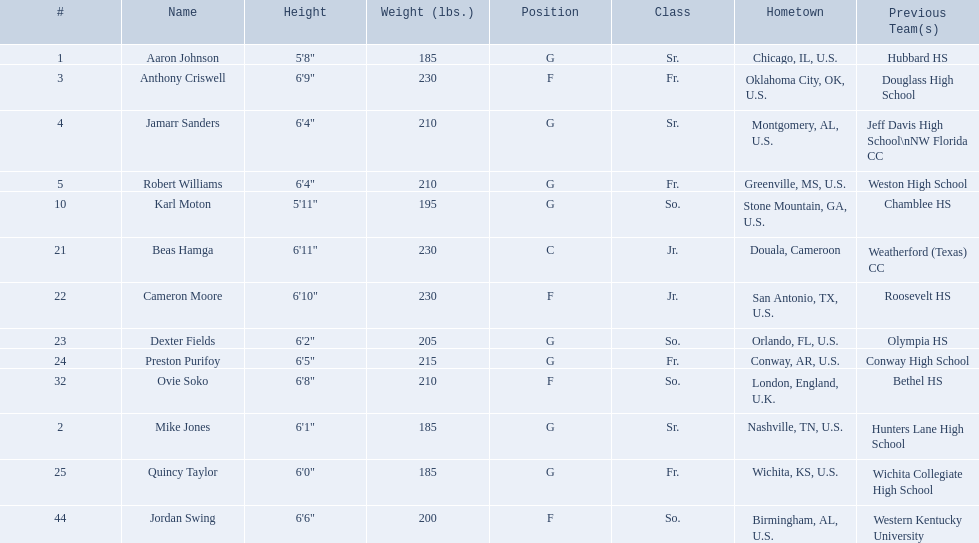Who are the complete list of players? Aaron Johnson, Anthony Criswell, Jamarr Sanders, Robert Williams, Karl Moton, Beas Hamga, Cameron Moore, Dexter Fields, Preston Purifoy, Ovie Soko, Mike Jones, Quincy Taylor, Jordan Swing. Which players come from countries other than the united states? Beas Hamga, Ovie Soko. Besides soko, who are the other non-u.s. players? Beas Hamga. 